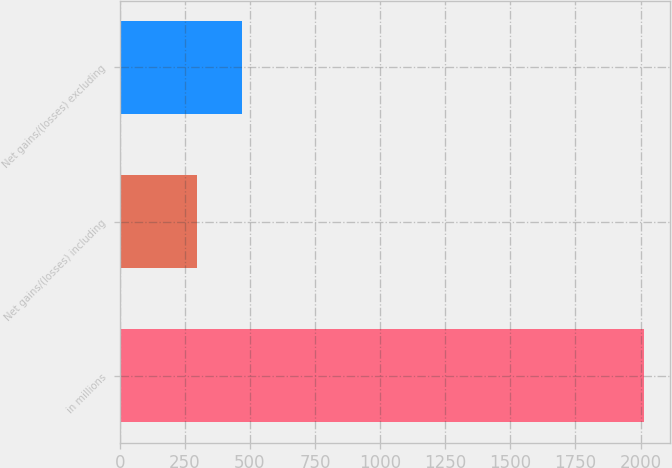Convert chart to OTSL. <chart><loc_0><loc_0><loc_500><loc_500><bar_chart><fcel>in millions<fcel>Net gains/(losses) including<fcel>Net gains/(losses) excluding<nl><fcel>2013<fcel>296<fcel>467.7<nl></chart> 